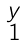Convert formula to latex. <formula><loc_0><loc_0><loc_500><loc_500>\begin{smallmatrix} y \\ 1 \end{smallmatrix}</formula> 